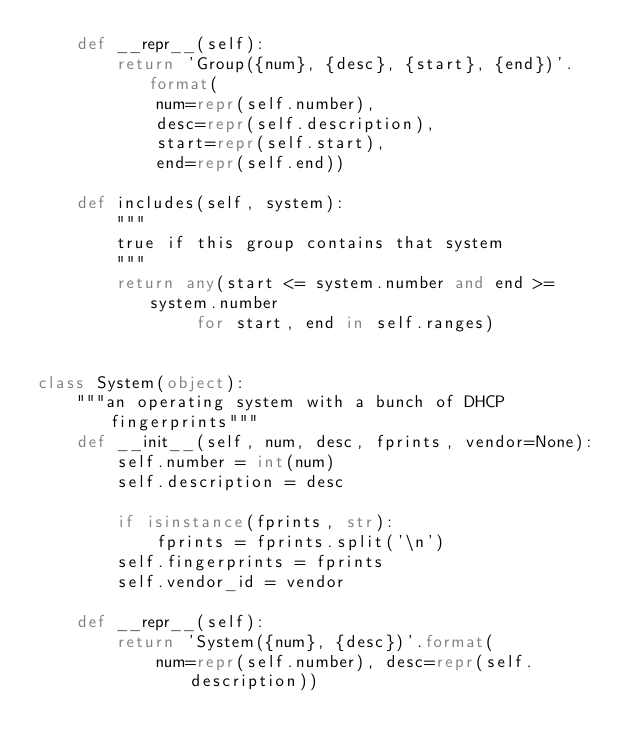Convert code to text. <code><loc_0><loc_0><loc_500><loc_500><_Python_>    def __repr__(self):
        return 'Group({num}, {desc}, {start}, {end})'.format(
            num=repr(self.number),
            desc=repr(self.description),
            start=repr(self.start),
            end=repr(self.end))

    def includes(self, system):
        """
        true if this group contains that system
        """
        return any(start <= system.number and end >= system.number
                for start, end in self.ranges)


class System(object):
    """an operating system with a bunch of DHCP fingerprints"""
    def __init__(self, num, desc, fprints, vendor=None):
        self.number = int(num)
        self.description = desc

        if isinstance(fprints, str):
            fprints = fprints.split('\n')
        self.fingerprints = fprints
        self.vendor_id = vendor

    def __repr__(self):
        return 'System({num}, {desc})'.format(
            num=repr(self.number), desc=repr(self.description))
</code> 